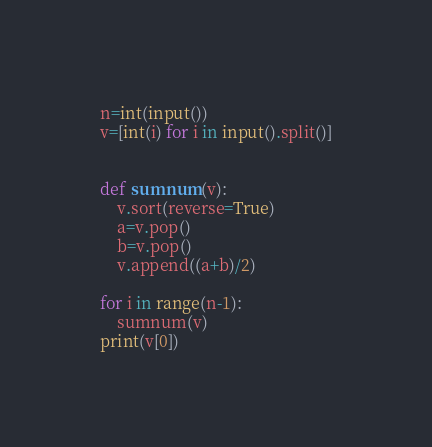<code> <loc_0><loc_0><loc_500><loc_500><_Python_>n=int(input())
v=[int(i) for i in input().split()]


def sumnum(v):
    v.sort(reverse=True)
    a=v.pop()
    b=v.pop()
    v.append((a+b)/2)

for i in range(n-1):
    sumnum(v)
print(v[0])</code> 